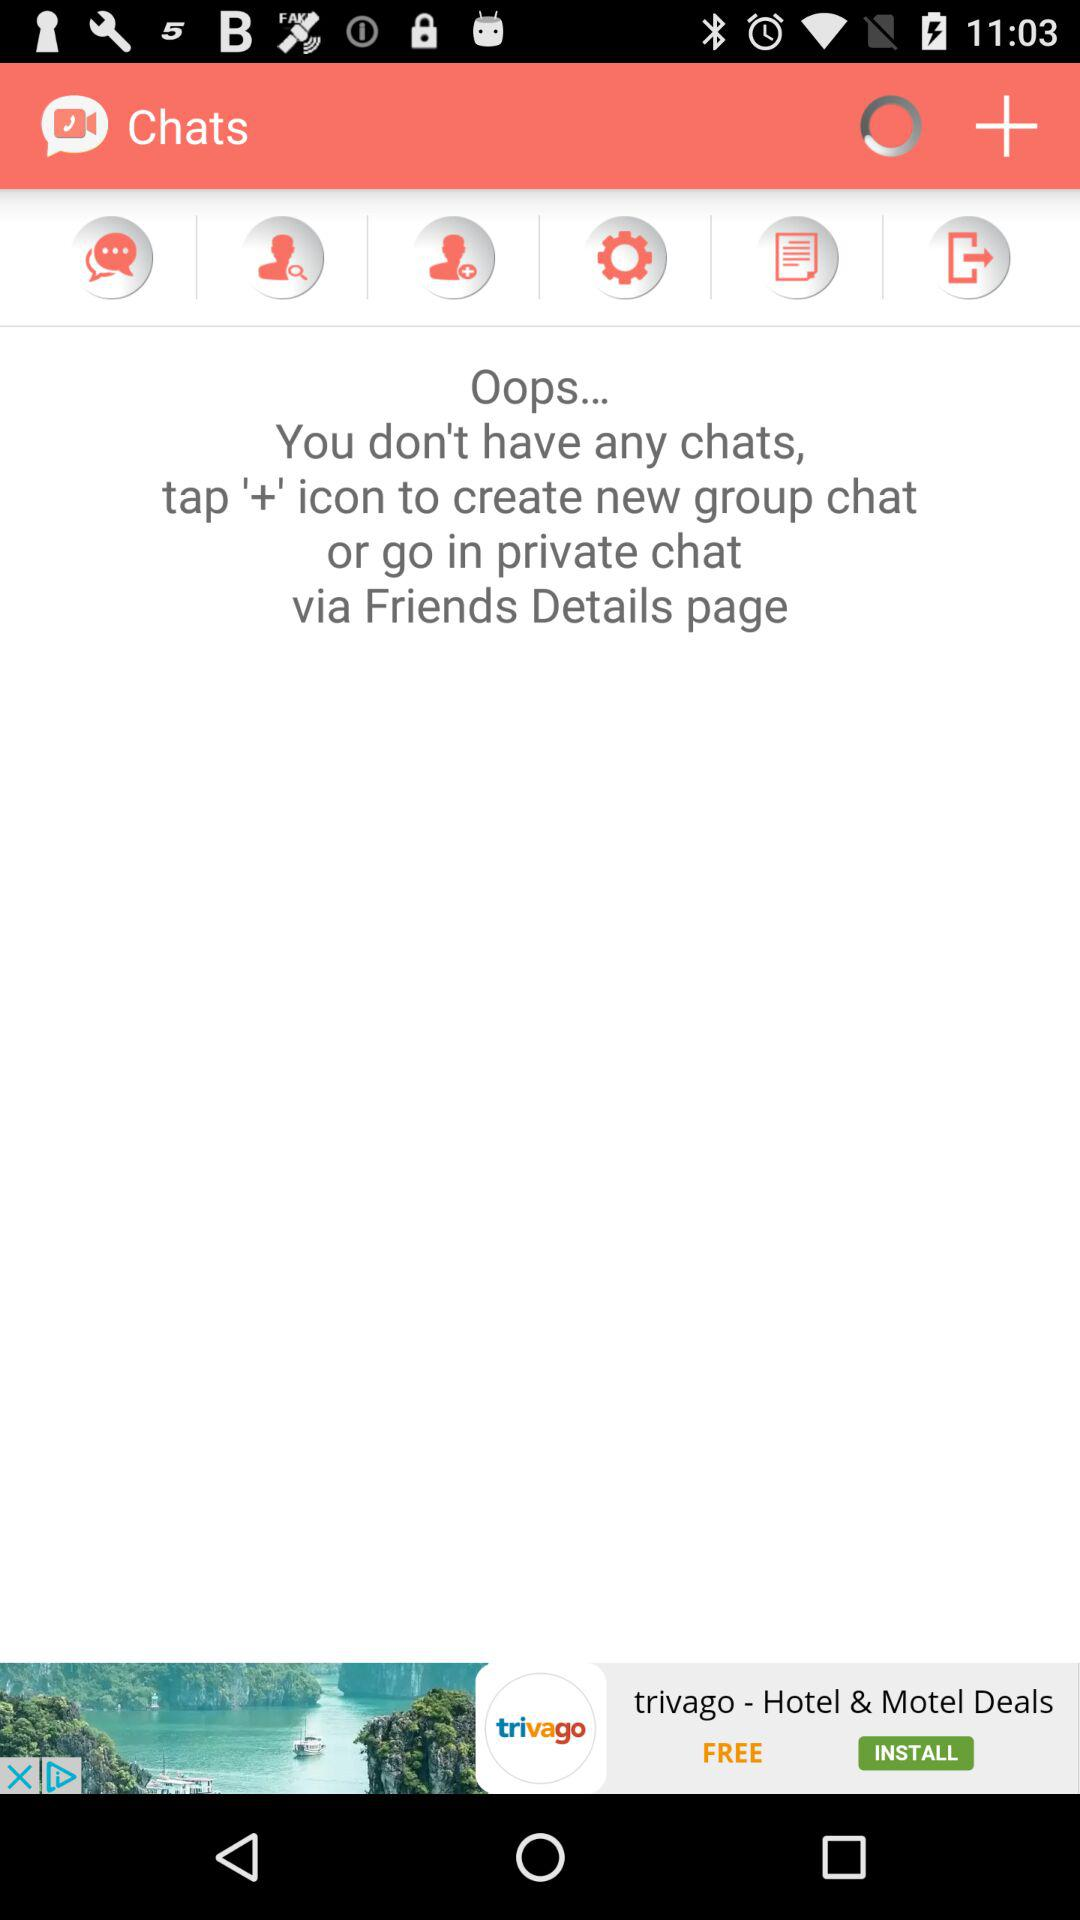What is the name of the application? The name of the application is "Chats". 